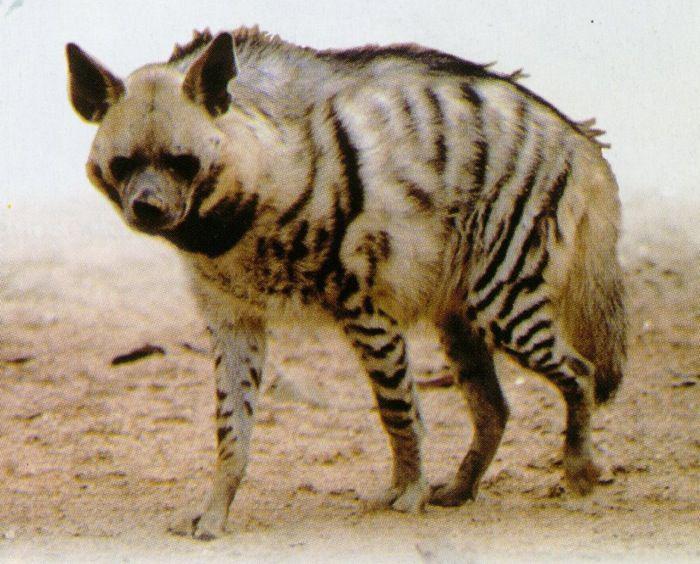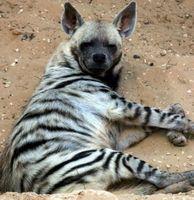The first image is the image on the left, the second image is the image on the right. Examine the images to the left and right. Is the description "there is exactly one animal lying down in one of the images" accurate? Answer yes or no. Yes. 